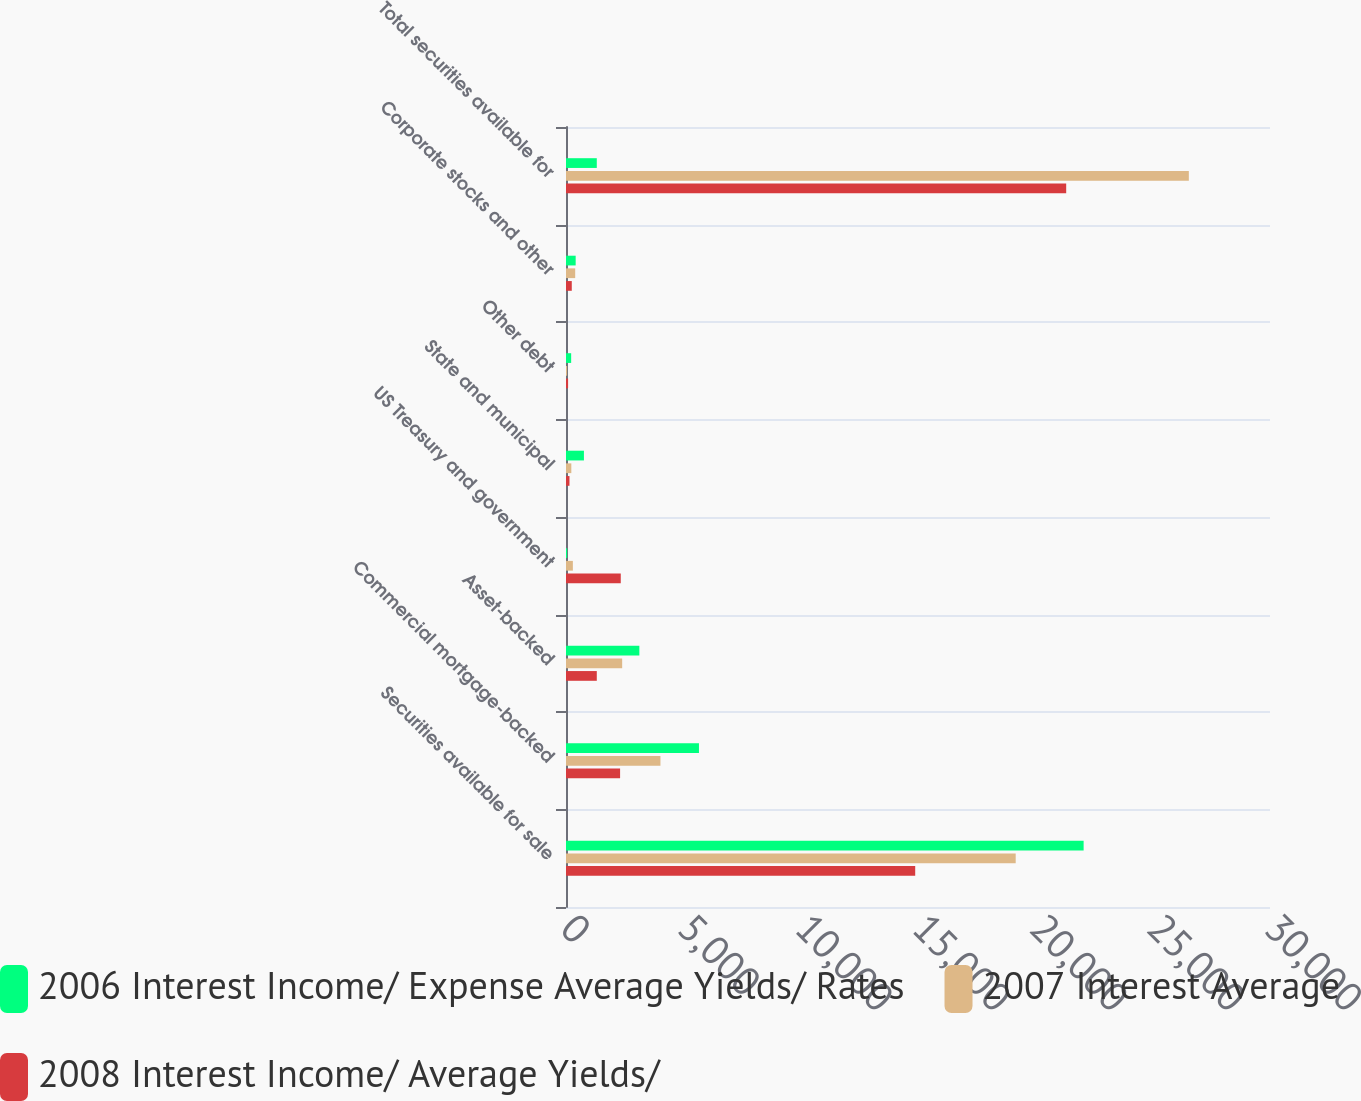Convert chart to OTSL. <chart><loc_0><loc_0><loc_500><loc_500><stacked_bar_chart><ecel><fcel>Securities available for sale<fcel>Commercial mortgage-backed<fcel>Asset-backed<fcel>US Treasury and government<fcel>State and municipal<fcel>Other debt<fcel>Corporate stocks and other<fcel>Total securities available for<nl><fcel>2006 Interest Income/ Expense Average Yields/ Rates<fcel>22058<fcel>5666<fcel>3126<fcel>50<fcel>764<fcel>220<fcel>412<fcel>1312<nl><fcel>2007 Interest Average<fcel>19163<fcel>4025<fcel>2394<fcel>293<fcel>227<fcel>47<fcel>392<fcel>26541<nl><fcel>2008 Interest Income/ Average Yields/<fcel>14881<fcel>2305<fcel>1312<fcel>2334<fcel>148<fcel>89<fcel>246<fcel>21315<nl></chart> 